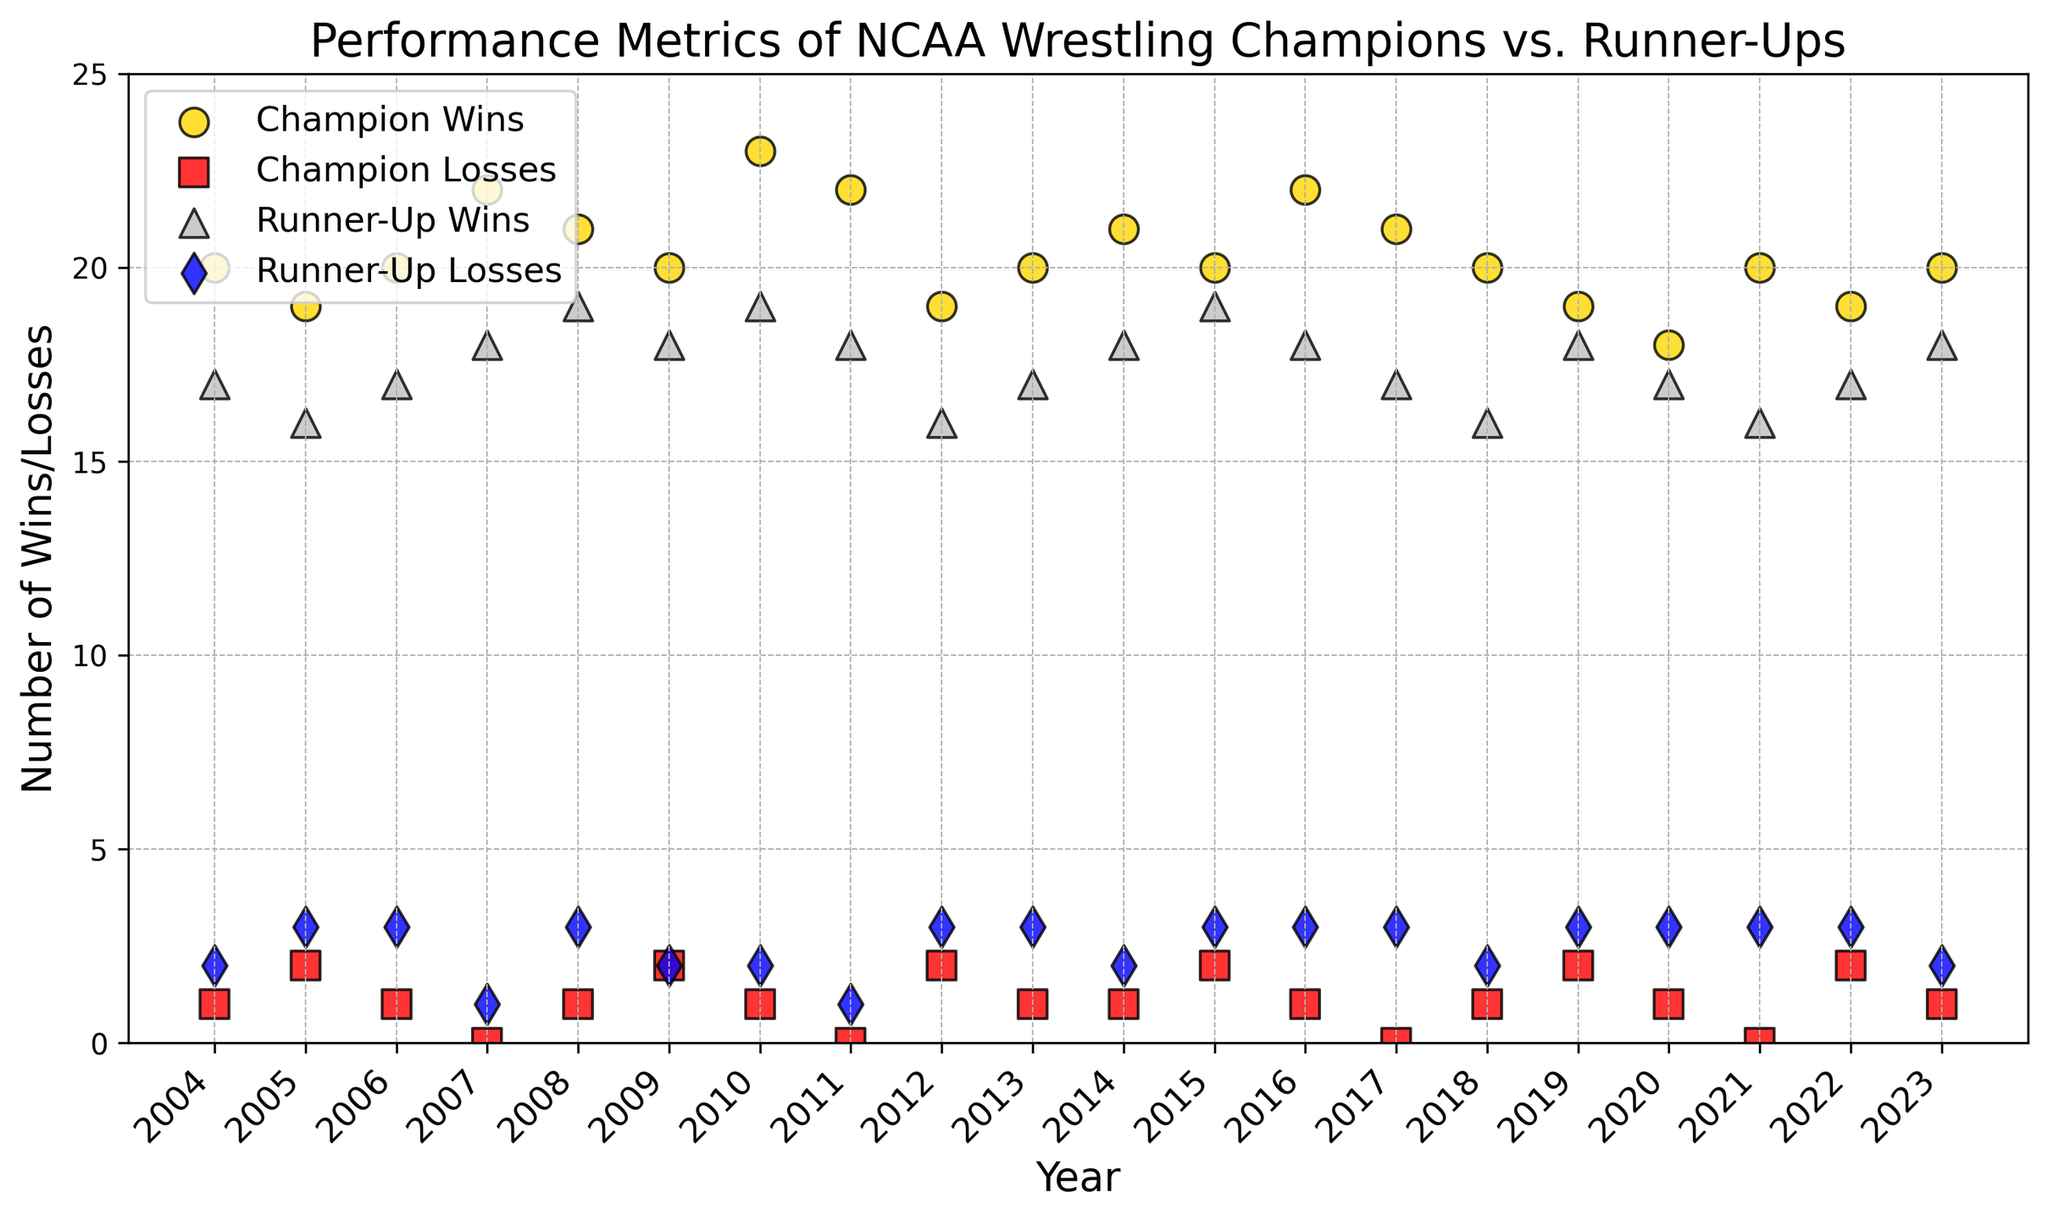Which year did the Champions achieve the highest number of wins? Look for the point with the highest value on the scatter plot representing Champion Wins. The gold marker peaks at 23 wins. Check the corresponding year on the x-axis to find the answer.
Answer: 2010 Comparing 2017 and 2018, which year saw fewer losses by the Runner-Up? Observe the blue markers representing Runner-Up Losses. The 2017 marker is at (Year: 2017, Losses: 3), and the 2018 marker is at (Year: 2018, Losses: 2). Fewer losses occurred in 2018.
Answer: 2018 What is the average number of wins for Champions over the last 20 years? Add up all the values of Champion Wins and divide by the total number of years (20). The sum is 427. Average = 427 / 20 = 21.35
Answer: 21.35 In which year did both the Champion and Runner-Up each have exactly 18 wins? Locate the points on the scatter plot where both gold (Champion Wins) and silver (Runner-Up Wins) markers are at 18. In 2019, both had 18 wins.
Answer: 2019 Which year saw the least number of wins for the Runner-Up, and how many wins were there? Look for the silver marker with the lowest value on the y-axis. The minimum Runner-Up Wins is 16, present in 2012, 2018, 2005, and 2006.
Answer: 16 (2012, 2018, 2005, 2006) How many times did the Runner-Up have more losses than the Champion had wins? Compare the red markers (Champion Losses) with blue markers (Runner-Up Losses). Count instances where Runner-Up Losses > Champion Wins. No such instances in the provided data.
Answer: 0 During which year did the Champion achieve a perfect season (zero losses), and how many times did this occur in the last 20 years? Find the red markers (Champion Losses) at zero. Those years are 2017, 2011, and 2007. Count the instances.
Answer: 3 times (2017, 2011, 2007) In what year did the Champion and Runner-Up have the most significant difference in wins, and what was the difference? Calculate the difference in wins for each year. The most significant difference is max(abs(Champion Wins - Runner-Up Wins)). In 2010, Champion had 23 wins and Runner-Up had 19 wins, difference = 4.
Answer: 2010, 4 wins How consistent were the win values among Champions compared to Runner-Ups? Visually inspect the range of win values. Champion Wins vary between 19 and 23, and Runner-Up Wins vary between 16 and 19. Champions show slightly more range within a narrower band of higher wins than Runner-Ups.
Answer: Champions more consistent, narrower range 